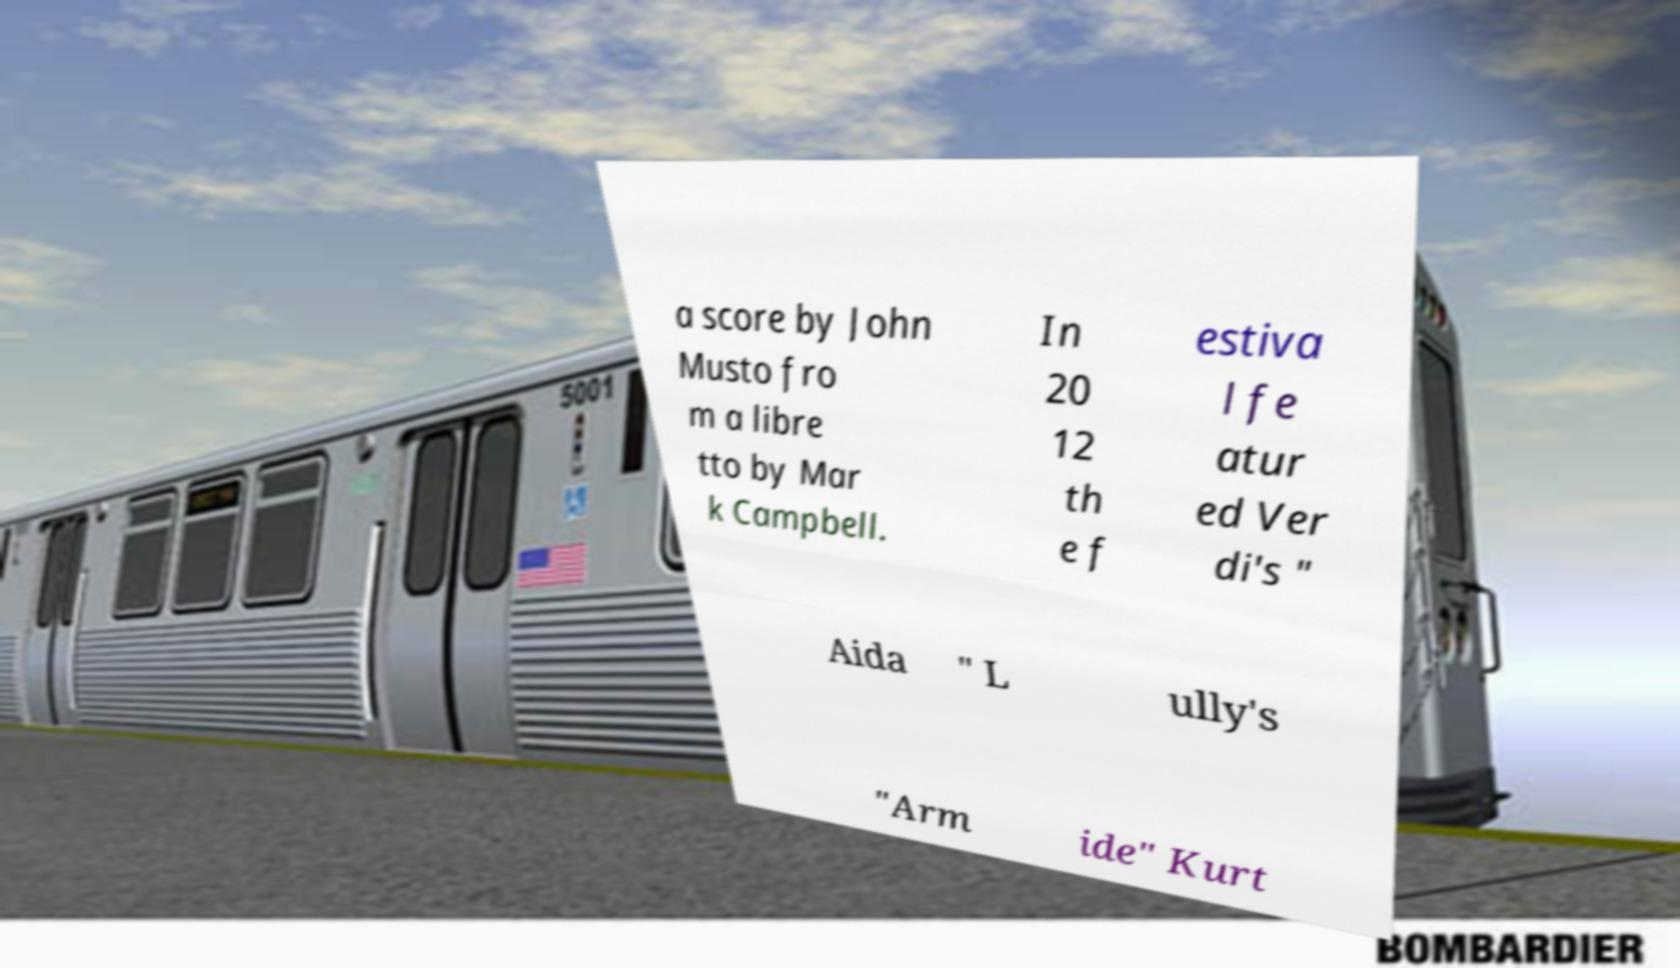There's text embedded in this image that I need extracted. Can you transcribe it verbatim? a score by John Musto fro m a libre tto by Mar k Campbell. In 20 12 th e f estiva l fe atur ed Ver di's " Aida " L ully's "Arm ide" Kurt 